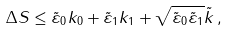Convert formula to latex. <formula><loc_0><loc_0><loc_500><loc_500>\Delta S \leq \tilde { \varepsilon } _ { 0 } k _ { 0 } + \tilde { \varepsilon } _ { 1 } k _ { 1 } + \sqrt { \tilde { \varepsilon } _ { 0 } \tilde { \varepsilon } _ { 1 } } \tilde { k } \, ,</formula> 